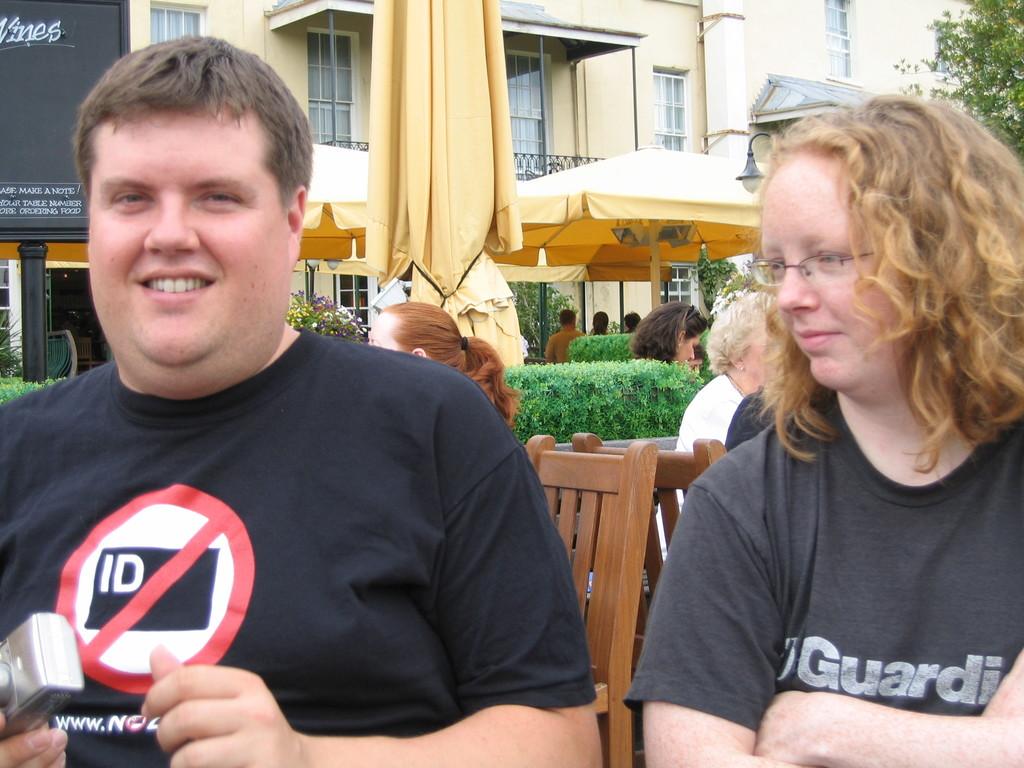What is the red sign saying no to?
Make the answer very short. Id. 